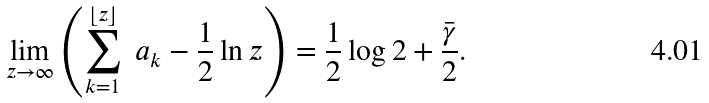<formula> <loc_0><loc_0><loc_500><loc_500>\lim _ { z \to \infty } \left ( \sum _ { k = 1 } ^ { \lfloor z \rfloor } \ a _ { k } - \frac { 1 } { 2 } \ln z \right ) = \frac { 1 } { 2 } \log 2 + \frac { \bar { \gamma } } { 2 } .</formula> 